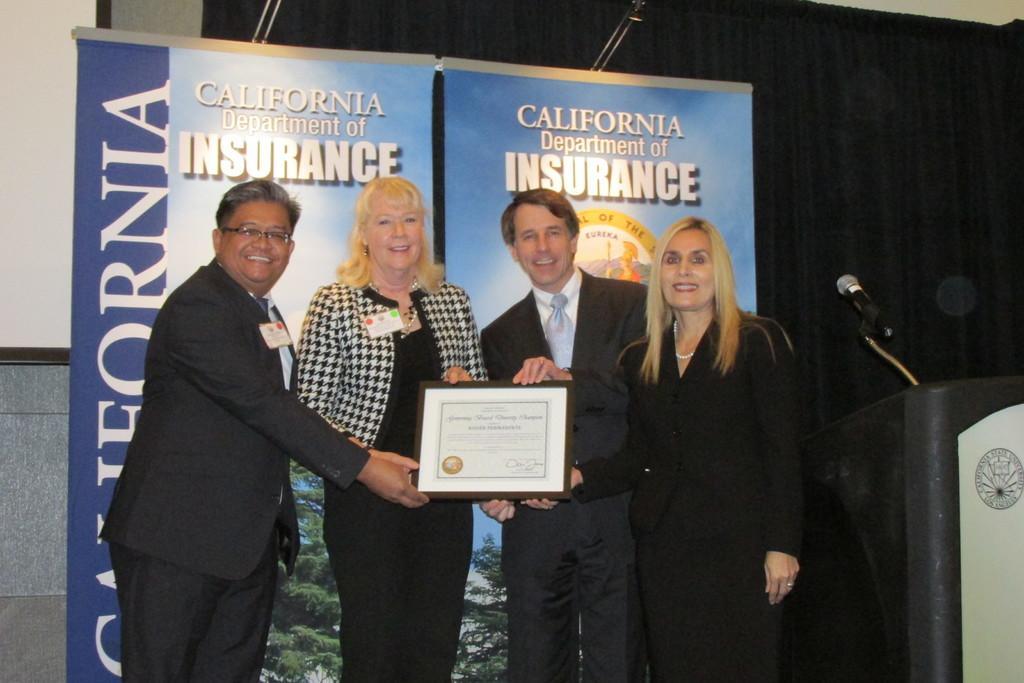Describe this image in one or two sentences. In the image we can see two men and two women standing, wearing clothes and they are smiling, two of them are wearing identity card and they are holding the frame in their hands. Here we can see podium, microphone, poster and text on the poster. Here we can see the curtains, lights and the wall. 